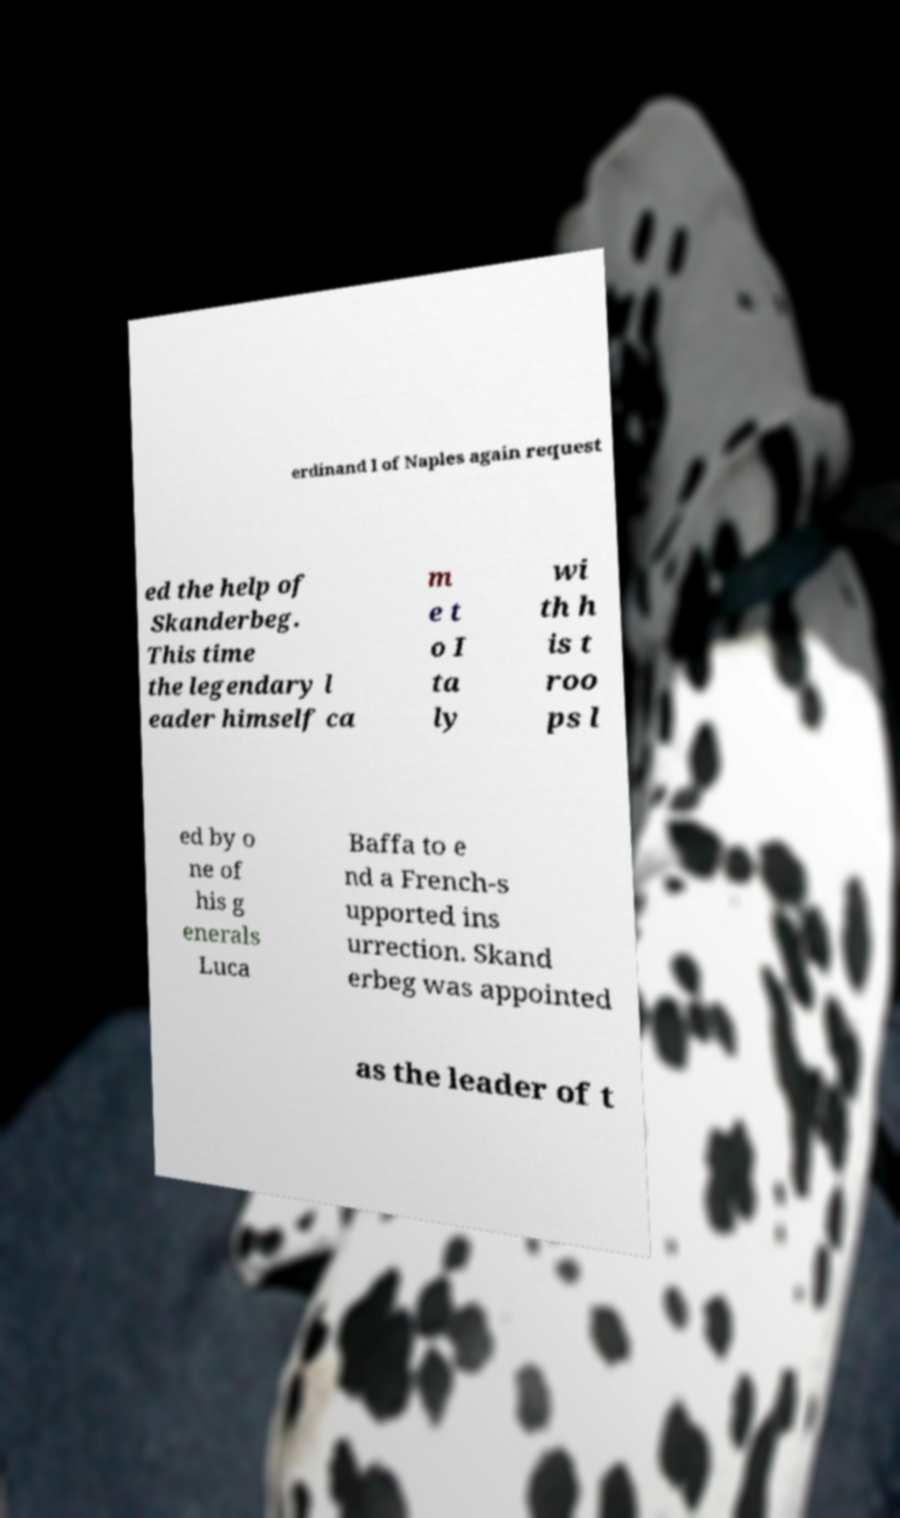There's text embedded in this image that I need extracted. Can you transcribe it verbatim? erdinand I of Naples again request ed the help of Skanderbeg. This time the legendary l eader himself ca m e t o I ta ly wi th h is t roo ps l ed by o ne of his g enerals Luca Baffa to e nd a French-s upported ins urrection. Skand erbeg was appointed as the leader of t 